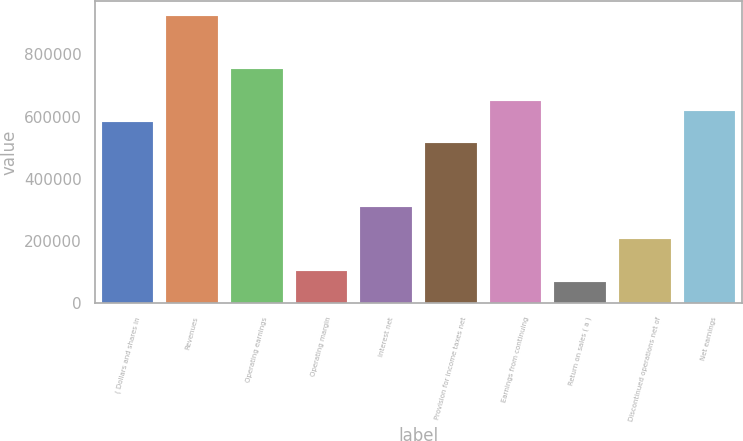Convert chart to OTSL. <chart><loc_0><loc_0><loc_500><loc_500><bar_chart><fcel>( Dollars and shares in<fcel>Revenues<fcel>Operating earnings<fcel>Operating margin<fcel>Interest net<fcel>Provision for income taxes net<fcel>Earnings from continuing<fcel>Return on sales ( a )<fcel>Discontinued operations net of<fcel>Net earnings<nl><fcel>582419<fcel>925018<fcel>753718<fcel>102781<fcel>308340<fcel>513899<fcel>650939<fcel>68521.1<fcel>205561<fcel>616679<nl></chart> 